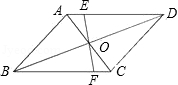Explain the details depicted in the figure. The diagram illustrates a parallelogram named ABCD. The diagonals AC and BD intersect at point O, splitting each other into two equal parts, a typical property of parallelograms. Additionally, a line EF is drawn which also passes through point O and extends from point E on side AD to point F on side BC, possibly suggesting the exploration of further geometric properties or constructions related to the parallelogram. 